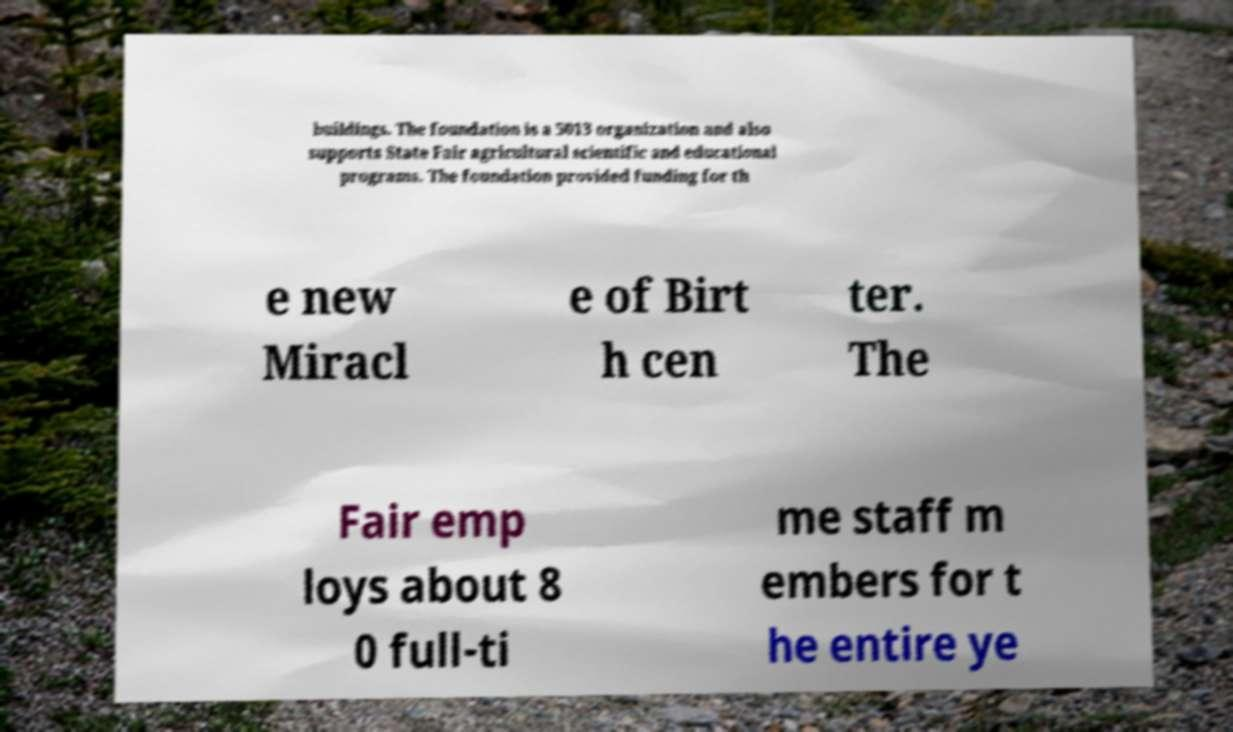For documentation purposes, I need the text within this image transcribed. Could you provide that? buildings. The foundation is a 5013 organization and also supports State Fair agricultural scientific and educational programs. The foundation provided funding for th e new Miracl e of Birt h cen ter. The Fair emp loys about 8 0 full-ti me staff m embers for t he entire ye 